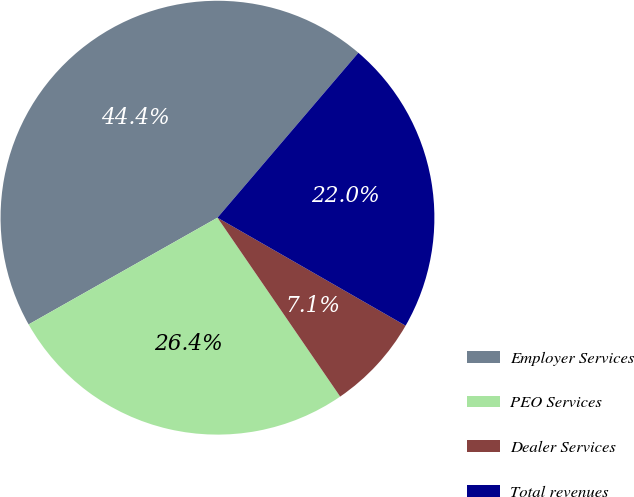Convert chart. <chart><loc_0><loc_0><loc_500><loc_500><pie_chart><fcel>Employer Services<fcel>PEO Services<fcel>Dealer Services<fcel>Total revenues<nl><fcel>44.44%<fcel>26.38%<fcel>7.14%<fcel>22.04%<nl></chart> 